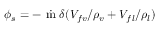<formula> <loc_0><loc_0><loc_500><loc_500>\phi _ { s } = - \dot { m } \delta ( V _ { f v } / \rho _ { v } + V _ { f l } / \rho _ { l } )</formula> 